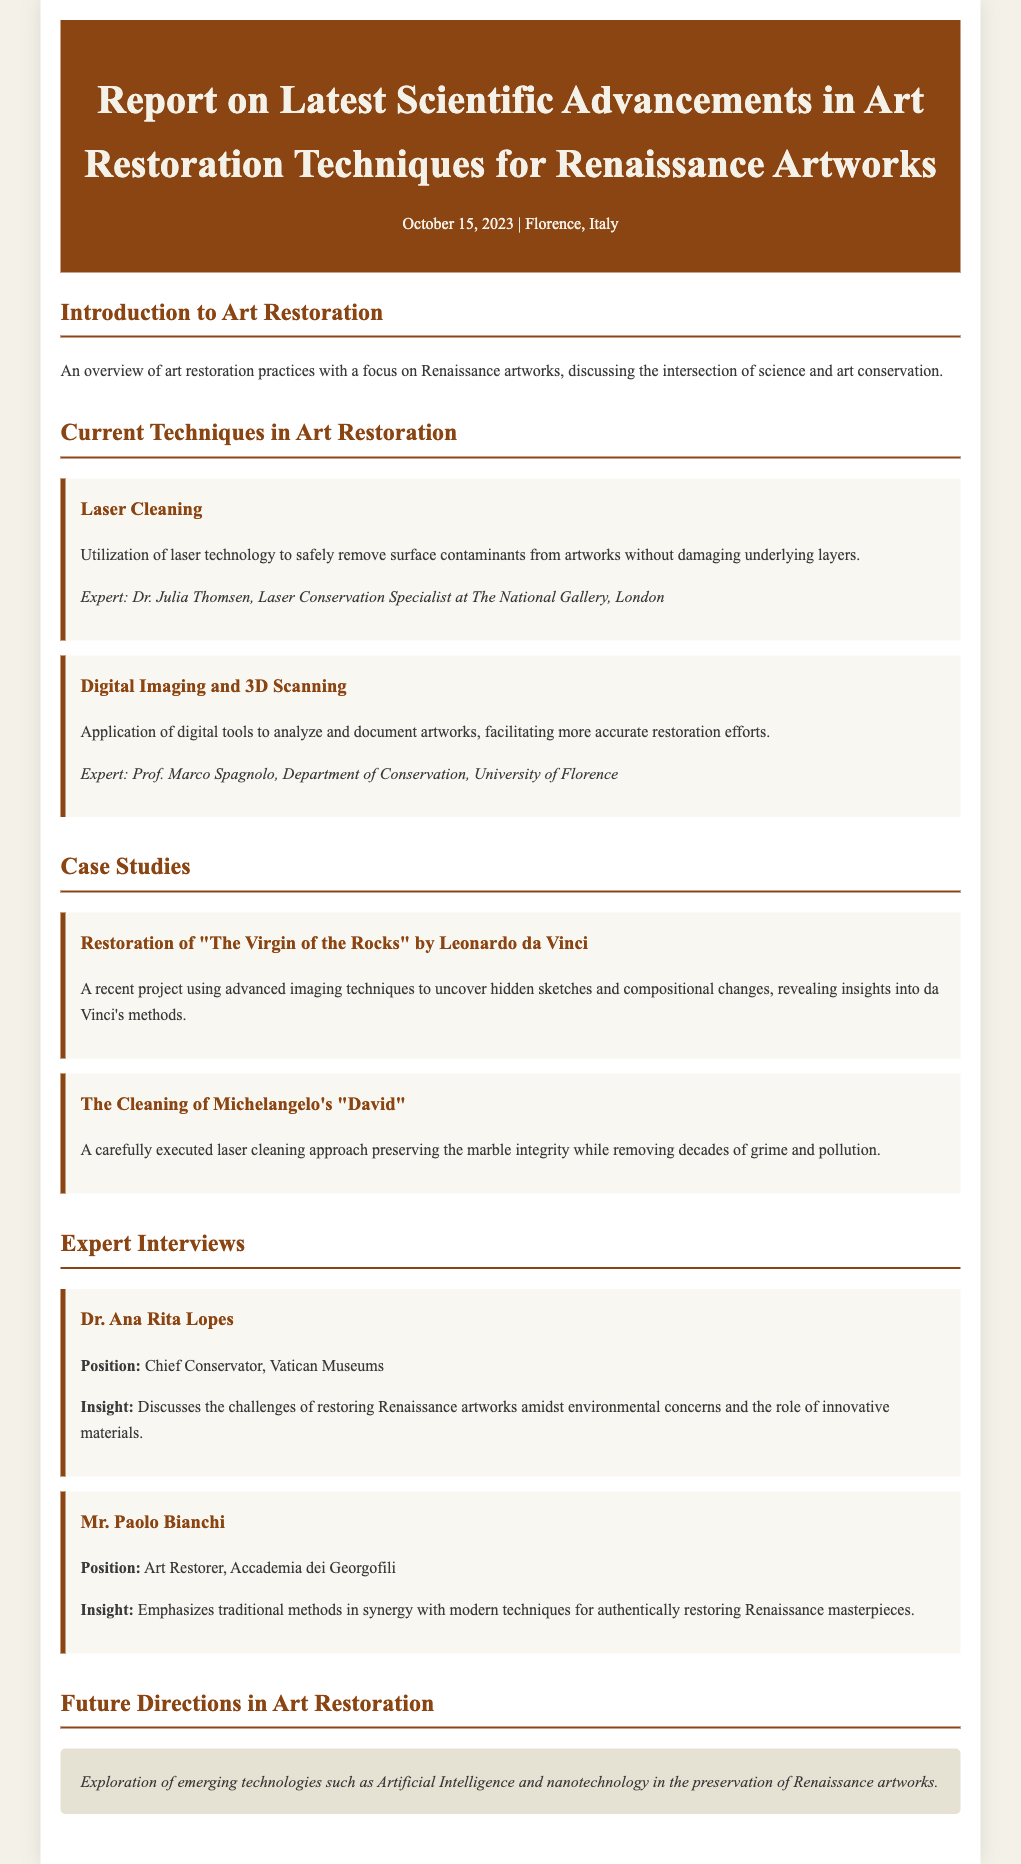What is the date of the report? The date of the report is mentioned at the top of the document as October 15, 2023.
Answer: October 15, 2023 Who is the expert on Laser Cleaning? The document lists Dr. Julia Thomsen as the expert on Laser Cleaning.
Answer: Dr. Julia Thomsen What is the focus of the introduction? The introduction discusses an overview of art restoration practices with a focus on Renaissance artworks.
Answer: Overview of art restoration practices How many case studies are included in the document? The document details two case studies, about "The Virgin of the Rocks" and Michelangelo's "David".
Answer: Two What innovative technology is mentioned for future directions in art restoration? The document mentions the exploration of Artificial Intelligence as an emerging technology for future art restoration.
Answer: Artificial Intelligence What position does Dr. Ana Rita Lopes hold? Dr. Ana Rita Lopes is identified as the Chief Conservator at the Vatican Museums in the document.
Answer: Chief Conservator What technique was used in the restoration of Michelangelo's "David"? The document states that a laser cleaning approach was used in the restoration of Michelangelo's "David".
Answer: Laser cleaning What insight does Mr. Paolo Bianchi emphasize? Mr. Paolo Bianchi emphasizes the synergy of traditional methods with modern techniques for restoring Renaissance masterpieces.
Answer: Traditional methods in synergy with modern techniques 